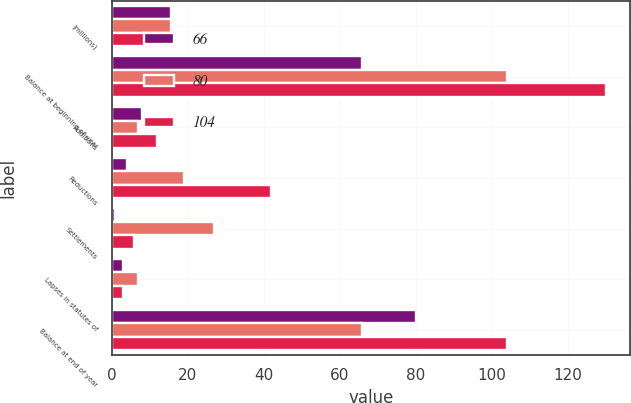Convert chart to OTSL. <chart><loc_0><loc_0><loc_500><loc_500><stacked_bar_chart><ecel><fcel>(millions)<fcel>Balance at beginning of year<fcel>Additions<fcel>Reductions<fcel>Settlements<fcel>Lapses in statutes of<fcel>Balance at end of year<nl><fcel>66<fcel>15.5<fcel>66<fcel>8<fcel>4<fcel>1<fcel>3<fcel>80<nl><fcel>80<fcel>15.5<fcel>104<fcel>7<fcel>19<fcel>27<fcel>7<fcel>66<nl><fcel>104<fcel>15.5<fcel>130<fcel>12<fcel>42<fcel>6<fcel>3<fcel>104<nl></chart> 